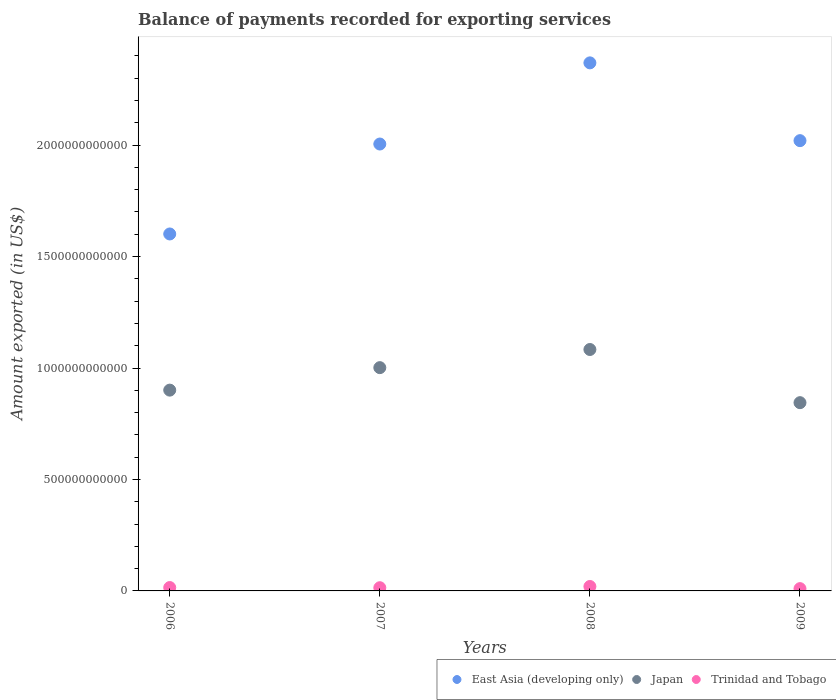Is the number of dotlines equal to the number of legend labels?
Offer a very short reply. Yes. What is the amount exported in Trinidad and Tobago in 2008?
Offer a terse response. 1.99e+1. Across all years, what is the maximum amount exported in Japan?
Your answer should be very brief. 1.08e+12. Across all years, what is the minimum amount exported in Japan?
Ensure brevity in your answer.  8.45e+11. What is the total amount exported in East Asia (developing only) in the graph?
Offer a very short reply. 7.99e+12. What is the difference between the amount exported in Trinidad and Tobago in 2006 and that in 2009?
Give a very brief answer. 4.87e+09. What is the difference between the amount exported in Japan in 2007 and the amount exported in Trinidad and Tobago in 2009?
Give a very brief answer. 9.91e+11. What is the average amount exported in Japan per year?
Keep it short and to the point. 9.57e+11. In the year 2009, what is the difference between the amount exported in Japan and amount exported in Trinidad and Tobago?
Keep it short and to the point. 8.34e+11. What is the ratio of the amount exported in Trinidad and Tobago in 2006 to that in 2009?
Provide a short and direct response. 1.47. Is the amount exported in Japan in 2008 less than that in 2009?
Offer a terse response. No. Is the difference between the amount exported in Japan in 2008 and 2009 greater than the difference between the amount exported in Trinidad and Tobago in 2008 and 2009?
Offer a terse response. Yes. What is the difference between the highest and the second highest amount exported in East Asia (developing only)?
Give a very brief answer. 3.49e+11. What is the difference between the highest and the lowest amount exported in Trinidad and Tobago?
Offer a terse response. 9.60e+09. In how many years, is the amount exported in Japan greater than the average amount exported in Japan taken over all years?
Offer a very short reply. 2. Is the sum of the amount exported in Japan in 2006 and 2009 greater than the maximum amount exported in East Asia (developing only) across all years?
Offer a very short reply. No. Does the amount exported in Trinidad and Tobago monotonically increase over the years?
Make the answer very short. No. Is the amount exported in Japan strictly less than the amount exported in East Asia (developing only) over the years?
Give a very brief answer. Yes. How many years are there in the graph?
Offer a terse response. 4. What is the difference between two consecutive major ticks on the Y-axis?
Provide a short and direct response. 5.00e+11. Are the values on the major ticks of Y-axis written in scientific E-notation?
Offer a very short reply. No. Does the graph contain grids?
Make the answer very short. No. Where does the legend appear in the graph?
Offer a very short reply. Bottom right. How are the legend labels stacked?
Your response must be concise. Horizontal. What is the title of the graph?
Keep it short and to the point. Balance of payments recorded for exporting services. Does "Moldova" appear as one of the legend labels in the graph?
Provide a succinct answer. No. What is the label or title of the X-axis?
Offer a very short reply. Years. What is the label or title of the Y-axis?
Your answer should be compact. Amount exported (in US$). What is the Amount exported (in US$) in East Asia (developing only) in 2006?
Give a very brief answer. 1.60e+12. What is the Amount exported (in US$) in Japan in 2006?
Give a very brief answer. 9.01e+11. What is the Amount exported (in US$) of Trinidad and Tobago in 2006?
Make the answer very short. 1.51e+1. What is the Amount exported (in US$) in East Asia (developing only) in 2007?
Provide a succinct answer. 2.00e+12. What is the Amount exported (in US$) in Japan in 2007?
Your answer should be compact. 1.00e+12. What is the Amount exported (in US$) of Trinidad and Tobago in 2007?
Keep it short and to the point. 1.44e+1. What is the Amount exported (in US$) in East Asia (developing only) in 2008?
Your answer should be compact. 2.37e+12. What is the Amount exported (in US$) in Japan in 2008?
Offer a very short reply. 1.08e+12. What is the Amount exported (in US$) of Trinidad and Tobago in 2008?
Your response must be concise. 1.99e+1. What is the Amount exported (in US$) in East Asia (developing only) in 2009?
Ensure brevity in your answer.  2.02e+12. What is the Amount exported (in US$) in Japan in 2009?
Your answer should be compact. 8.45e+11. What is the Amount exported (in US$) of Trinidad and Tobago in 2009?
Offer a terse response. 1.03e+1. Across all years, what is the maximum Amount exported (in US$) of East Asia (developing only)?
Make the answer very short. 2.37e+12. Across all years, what is the maximum Amount exported (in US$) in Japan?
Provide a short and direct response. 1.08e+12. Across all years, what is the maximum Amount exported (in US$) in Trinidad and Tobago?
Offer a terse response. 1.99e+1. Across all years, what is the minimum Amount exported (in US$) in East Asia (developing only)?
Give a very brief answer. 1.60e+12. Across all years, what is the minimum Amount exported (in US$) of Japan?
Offer a terse response. 8.45e+11. Across all years, what is the minimum Amount exported (in US$) in Trinidad and Tobago?
Provide a succinct answer. 1.03e+1. What is the total Amount exported (in US$) of East Asia (developing only) in the graph?
Provide a short and direct response. 7.99e+12. What is the total Amount exported (in US$) in Japan in the graph?
Your answer should be very brief. 3.83e+12. What is the total Amount exported (in US$) of Trinidad and Tobago in the graph?
Make the answer very short. 5.97e+1. What is the difference between the Amount exported (in US$) of East Asia (developing only) in 2006 and that in 2007?
Keep it short and to the point. -4.03e+11. What is the difference between the Amount exported (in US$) of Japan in 2006 and that in 2007?
Your response must be concise. -1.01e+11. What is the difference between the Amount exported (in US$) of Trinidad and Tobago in 2006 and that in 2007?
Ensure brevity in your answer.  7.53e+08. What is the difference between the Amount exported (in US$) of East Asia (developing only) in 2006 and that in 2008?
Offer a terse response. -7.68e+11. What is the difference between the Amount exported (in US$) of Japan in 2006 and that in 2008?
Your answer should be very brief. -1.82e+11. What is the difference between the Amount exported (in US$) in Trinidad and Tobago in 2006 and that in 2008?
Your answer should be compact. -4.73e+09. What is the difference between the Amount exported (in US$) in East Asia (developing only) in 2006 and that in 2009?
Ensure brevity in your answer.  -4.19e+11. What is the difference between the Amount exported (in US$) of Japan in 2006 and that in 2009?
Give a very brief answer. 5.62e+1. What is the difference between the Amount exported (in US$) of Trinidad and Tobago in 2006 and that in 2009?
Give a very brief answer. 4.87e+09. What is the difference between the Amount exported (in US$) of East Asia (developing only) in 2007 and that in 2008?
Provide a succinct answer. -3.64e+11. What is the difference between the Amount exported (in US$) in Japan in 2007 and that in 2008?
Provide a succinct answer. -8.14e+1. What is the difference between the Amount exported (in US$) in Trinidad and Tobago in 2007 and that in 2008?
Provide a succinct answer. -5.48e+09. What is the difference between the Amount exported (in US$) of East Asia (developing only) in 2007 and that in 2009?
Provide a succinct answer. -1.51e+1. What is the difference between the Amount exported (in US$) in Japan in 2007 and that in 2009?
Your response must be concise. 1.57e+11. What is the difference between the Amount exported (in US$) in Trinidad and Tobago in 2007 and that in 2009?
Give a very brief answer. 4.12e+09. What is the difference between the Amount exported (in US$) of East Asia (developing only) in 2008 and that in 2009?
Keep it short and to the point. 3.49e+11. What is the difference between the Amount exported (in US$) of Japan in 2008 and that in 2009?
Your answer should be compact. 2.38e+11. What is the difference between the Amount exported (in US$) in Trinidad and Tobago in 2008 and that in 2009?
Ensure brevity in your answer.  9.60e+09. What is the difference between the Amount exported (in US$) in East Asia (developing only) in 2006 and the Amount exported (in US$) in Japan in 2007?
Provide a short and direct response. 6.00e+11. What is the difference between the Amount exported (in US$) in East Asia (developing only) in 2006 and the Amount exported (in US$) in Trinidad and Tobago in 2007?
Ensure brevity in your answer.  1.59e+12. What is the difference between the Amount exported (in US$) in Japan in 2006 and the Amount exported (in US$) in Trinidad and Tobago in 2007?
Make the answer very short. 8.86e+11. What is the difference between the Amount exported (in US$) of East Asia (developing only) in 2006 and the Amount exported (in US$) of Japan in 2008?
Your response must be concise. 5.18e+11. What is the difference between the Amount exported (in US$) in East Asia (developing only) in 2006 and the Amount exported (in US$) in Trinidad and Tobago in 2008?
Keep it short and to the point. 1.58e+12. What is the difference between the Amount exported (in US$) in Japan in 2006 and the Amount exported (in US$) in Trinidad and Tobago in 2008?
Give a very brief answer. 8.81e+11. What is the difference between the Amount exported (in US$) of East Asia (developing only) in 2006 and the Amount exported (in US$) of Japan in 2009?
Make the answer very short. 7.57e+11. What is the difference between the Amount exported (in US$) in East Asia (developing only) in 2006 and the Amount exported (in US$) in Trinidad and Tobago in 2009?
Make the answer very short. 1.59e+12. What is the difference between the Amount exported (in US$) in Japan in 2006 and the Amount exported (in US$) in Trinidad and Tobago in 2009?
Ensure brevity in your answer.  8.90e+11. What is the difference between the Amount exported (in US$) in East Asia (developing only) in 2007 and the Amount exported (in US$) in Japan in 2008?
Keep it short and to the point. 9.22e+11. What is the difference between the Amount exported (in US$) in East Asia (developing only) in 2007 and the Amount exported (in US$) in Trinidad and Tobago in 2008?
Ensure brevity in your answer.  1.98e+12. What is the difference between the Amount exported (in US$) of Japan in 2007 and the Amount exported (in US$) of Trinidad and Tobago in 2008?
Ensure brevity in your answer.  9.82e+11. What is the difference between the Amount exported (in US$) in East Asia (developing only) in 2007 and the Amount exported (in US$) in Japan in 2009?
Provide a short and direct response. 1.16e+12. What is the difference between the Amount exported (in US$) in East Asia (developing only) in 2007 and the Amount exported (in US$) in Trinidad and Tobago in 2009?
Your answer should be very brief. 1.99e+12. What is the difference between the Amount exported (in US$) in Japan in 2007 and the Amount exported (in US$) in Trinidad and Tobago in 2009?
Your answer should be very brief. 9.91e+11. What is the difference between the Amount exported (in US$) in East Asia (developing only) in 2008 and the Amount exported (in US$) in Japan in 2009?
Make the answer very short. 1.52e+12. What is the difference between the Amount exported (in US$) of East Asia (developing only) in 2008 and the Amount exported (in US$) of Trinidad and Tobago in 2009?
Give a very brief answer. 2.36e+12. What is the difference between the Amount exported (in US$) in Japan in 2008 and the Amount exported (in US$) in Trinidad and Tobago in 2009?
Make the answer very short. 1.07e+12. What is the average Amount exported (in US$) in East Asia (developing only) per year?
Ensure brevity in your answer.  2.00e+12. What is the average Amount exported (in US$) in Japan per year?
Keep it short and to the point. 9.57e+11. What is the average Amount exported (in US$) of Trinidad and Tobago per year?
Your response must be concise. 1.49e+1. In the year 2006, what is the difference between the Amount exported (in US$) of East Asia (developing only) and Amount exported (in US$) of Japan?
Your response must be concise. 7.01e+11. In the year 2006, what is the difference between the Amount exported (in US$) of East Asia (developing only) and Amount exported (in US$) of Trinidad and Tobago?
Offer a terse response. 1.59e+12. In the year 2006, what is the difference between the Amount exported (in US$) of Japan and Amount exported (in US$) of Trinidad and Tobago?
Your answer should be compact. 8.86e+11. In the year 2007, what is the difference between the Amount exported (in US$) in East Asia (developing only) and Amount exported (in US$) in Japan?
Your answer should be very brief. 1.00e+12. In the year 2007, what is the difference between the Amount exported (in US$) of East Asia (developing only) and Amount exported (in US$) of Trinidad and Tobago?
Make the answer very short. 1.99e+12. In the year 2007, what is the difference between the Amount exported (in US$) in Japan and Amount exported (in US$) in Trinidad and Tobago?
Give a very brief answer. 9.87e+11. In the year 2008, what is the difference between the Amount exported (in US$) of East Asia (developing only) and Amount exported (in US$) of Japan?
Keep it short and to the point. 1.29e+12. In the year 2008, what is the difference between the Amount exported (in US$) in East Asia (developing only) and Amount exported (in US$) in Trinidad and Tobago?
Your response must be concise. 2.35e+12. In the year 2008, what is the difference between the Amount exported (in US$) in Japan and Amount exported (in US$) in Trinidad and Tobago?
Provide a short and direct response. 1.06e+12. In the year 2009, what is the difference between the Amount exported (in US$) of East Asia (developing only) and Amount exported (in US$) of Japan?
Provide a succinct answer. 1.18e+12. In the year 2009, what is the difference between the Amount exported (in US$) of East Asia (developing only) and Amount exported (in US$) of Trinidad and Tobago?
Offer a very short reply. 2.01e+12. In the year 2009, what is the difference between the Amount exported (in US$) in Japan and Amount exported (in US$) in Trinidad and Tobago?
Offer a terse response. 8.34e+11. What is the ratio of the Amount exported (in US$) of East Asia (developing only) in 2006 to that in 2007?
Provide a succinct answer. 0.8. What is the ratio of the Amount exported (in US$) of Japan in 2006 to that in 2007?
Offer a terse response. 0.9. What is the ratio of the Amount exported (in US$) in Trinidad and Tobago in 2006 to that in 2007?
Your answer should be very brief. 1.05. What is the ratio of the Amount exported (in US$) in East Asia (developing only) in 2006 to that in 2008?
Keep it short and to the point. 0.68. What is the ratio of the Amount exported (in US$) in Japan in 2006 to that in 2008?
Give a very brief answer. 0.83. What is the ratio of the Amount exported (in US$) in Trinidad and Tobago in 2006 to that in 2008?
Make the answer very short. 0.76. What is the ratio of the Amount exported (in US$) in East Asia (developing only) in 2006 to that in 2009?
Provide a short and direct response. 0.79. What is the ratio of the Amount exported (in US$) in Japan in 2006 to that in 2009?
Keep it short and to the point. 1.07. What is the ratio of the Amount exported (in US$) of Trinidad and Tobago in 2006 to that in 2009?
Offer a terse response. 1.47. What is the ratio of the Amount exported (in US$) in East Asia (developing only) in 2007 to that in 2008?
Ensure brevity in your answer.  0.85. What is the ratio of the Amount exported (in US$) of Japan in 2007 to that in 2008?
Your response must be concise. 0.92. What is the ratio of the Amount exported (in US$) in Trinidad and Tobago in 2007 to that in 2008?
Make the answer very short. 0.72. What is the ratio of the Amount exported (in US$) in East Asia (developing only) in 2007 to that in 2009?
Make the answer very short. 0.99. What is the ratio of the Amount exported (in US$) in Japan in 2007 to that in 2009?
Provide a succinct answer. 1.19. What is the ratio of the Amount exported (in US$) of Trinidad and Tobago in 2007 to that in 2009?
Give a very brief answer. 1.4. What is the ratio of the Amount exported (in US$) in East Asia (developing only) in 2008 to that in 2009?
Provide a succinct answer. 1.17. What is the ratio of the Amount exported (in US$) of Japan in 2008 to that in 2009?
Offer a terse response. 1.28. What is the ratio of the Amount exported (in US$) of Trinidad and Tobago in 2008 to that in 2009?
Give a very brief answer. 1.94. What is the difference between the highest and the second highest Amount exported (in US$) in East Asia (developing only)?
Your response must be concise. 3.49e+11. What is the difference between the highest and the second highest Amount exported (in US$) of Japan?
Your answer should be compact. 8.14e+1. What is the difference between the highest and the second highest Amount exported (in US$) in Trinidad and Tobago?
Offer a very short reply. 4.73e+09. What is the difference between the highest and the lowest Amount exported (in US$) of East Asia (developing only)?
Keep it short and to the point. 7.68e+11. What is the difference between the highest and the lowest Amount exported (in US$) of Japan?
Provide a succinct answer. 2.38e+11. What is the difference between the highest and the lowest Amount exported (in US$) of Trinidad and Tobago?
Ensure brevity in your answer.  9.60e+09. 